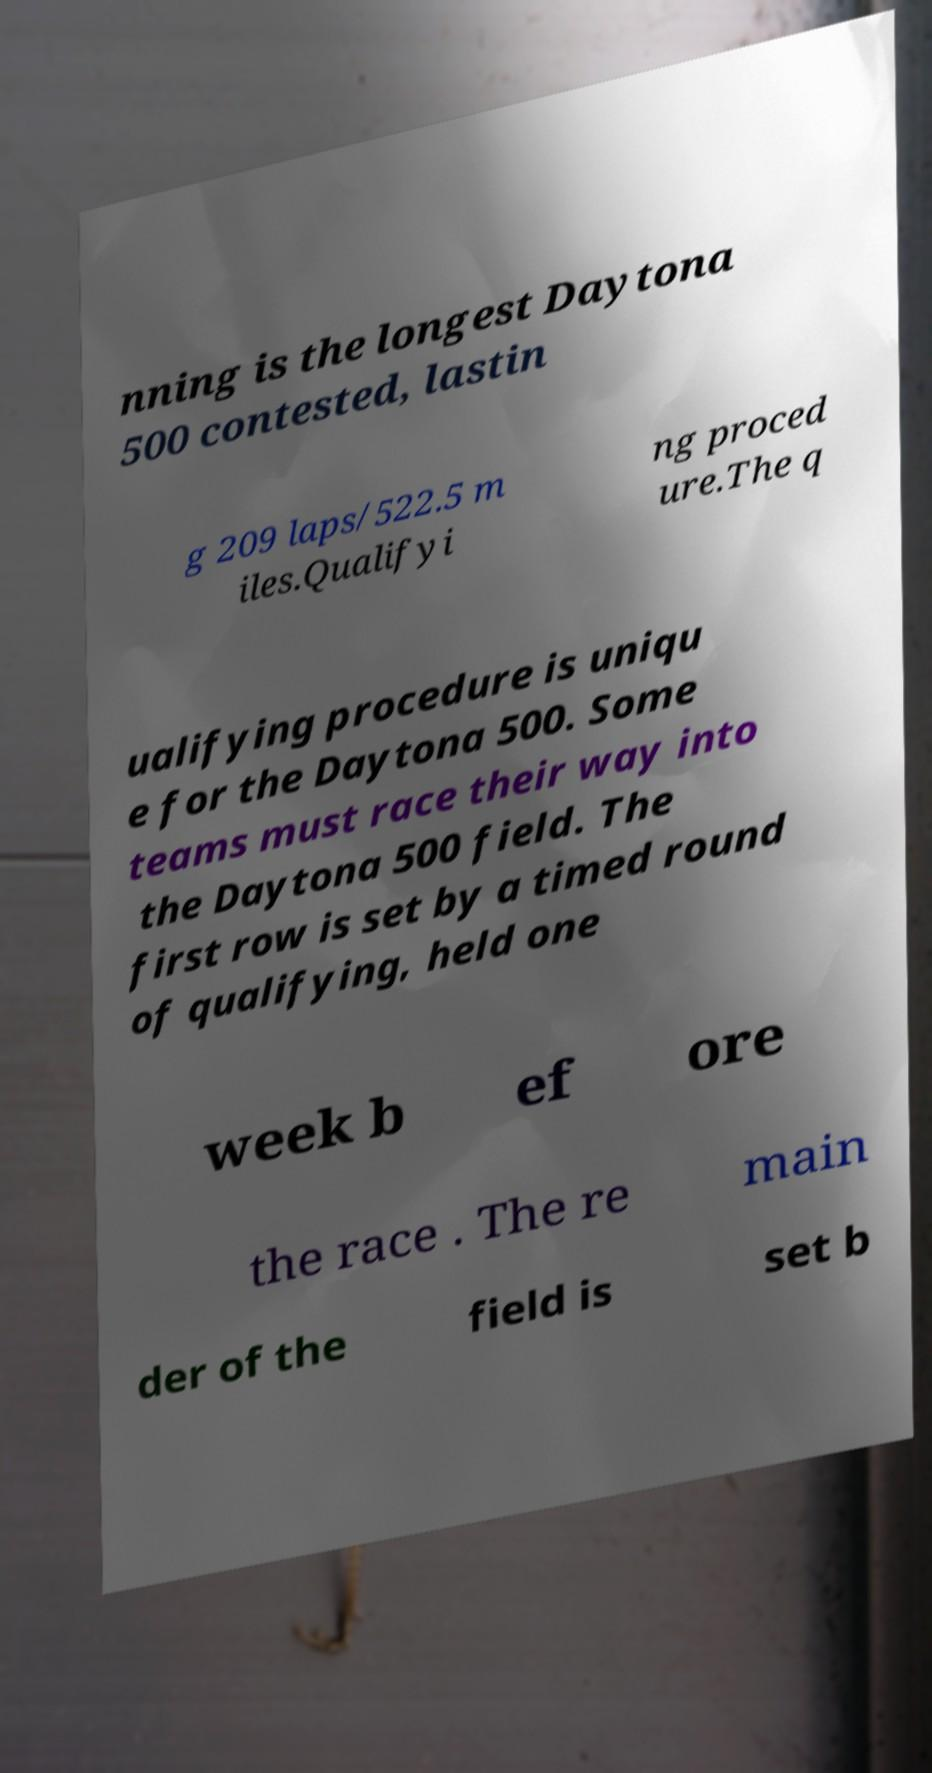What messages or text are displayed in this image? I need them in a readable, typed format. nning is the longest Daytona 500 contested, lastin g 209 laps/522.5 m iles.Qualifyi ng proced ure.The q ualifying procedure is uniqu e for the Daytona 500. Some teams must race their way into the Daytona 500 field. The first row is set by a timed round of qualifying, held one week b ef ore the race . The re main der of the field is set b 